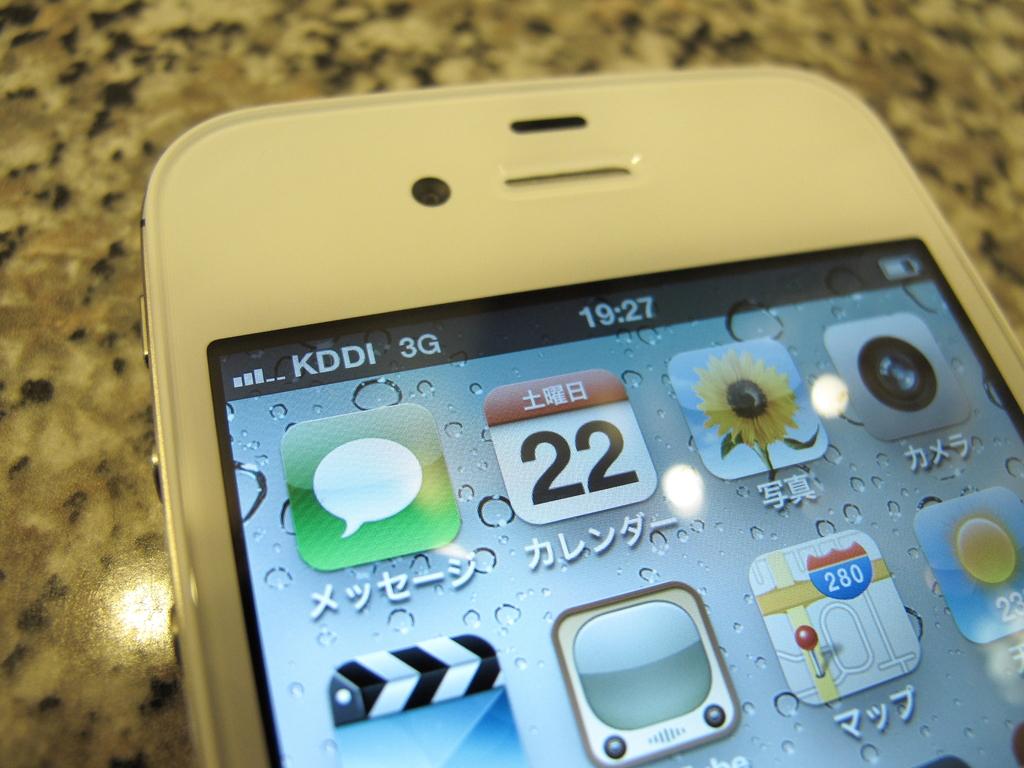What is the date on the calendar app?
Make the answer very short. 22. 